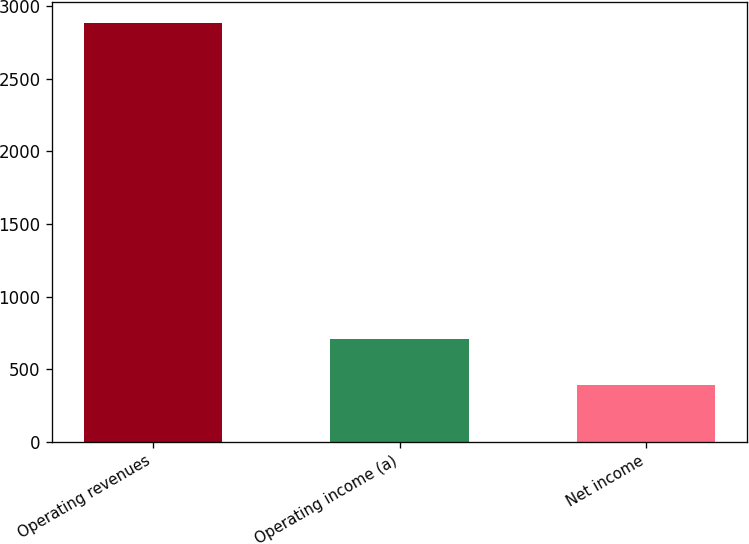Convert chart to OTSL. <chart><loc_0><loc_0><loc_500><loc_500><bar_chart><fcel>Operating revenues<fcel>Operating income (a)<fcel>Net income<nl><fcel>2884<fcel>705<fcel>389<nl></chart> 